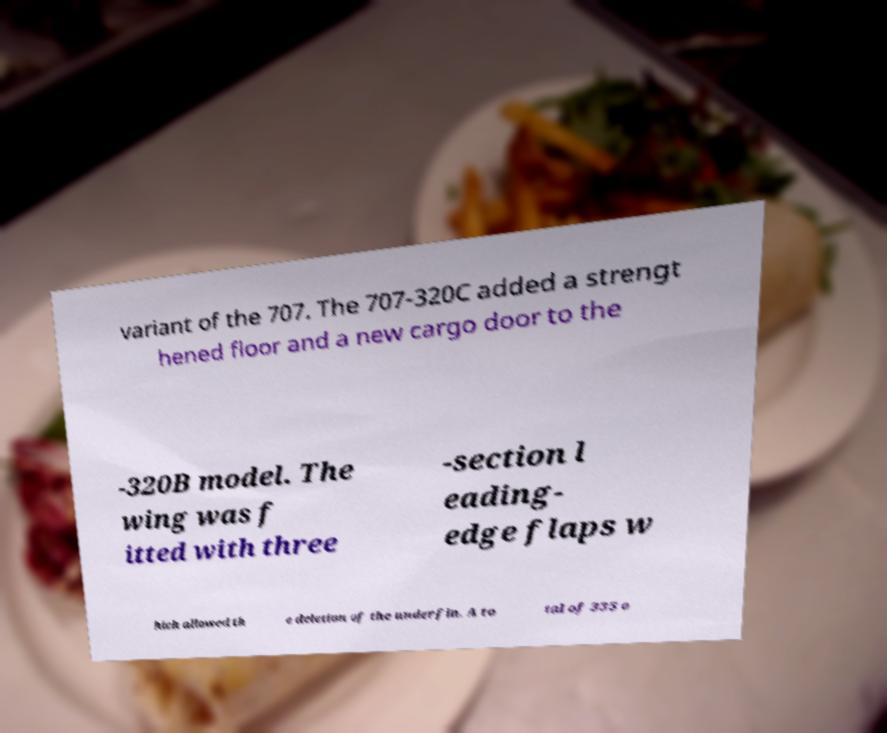Can you read and provide the text displayed in the image?This photo seems to have some interesting text. Can you extract and type it out for me? variant of the 707. The 707-320C added a strengt hened floor and a new cargo door to the -320B model. The wing was f itted with three -section l eading- edge flaps w hich allowed th e deletion of the underfin. A to tal of 335 o 